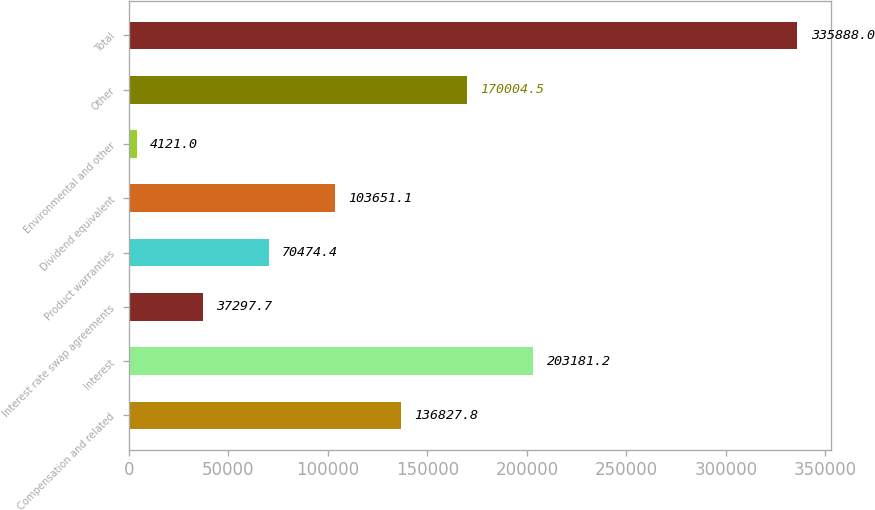Convert chart to OTSL. <chart><loc_0><loc_0><loc_500><loc_500><bar_chart><fcel>Compensation and related<fcel>Interest<fcel>Interest rate swap agreements<fcel>Product warranties<fcel>Dividend equivalent<fcel>Environmental and other<fcel>Other<fcel>Total<nl><fcel>136828<fcel>203181<fcel>37297.7<fcel>70474.4<fcel>103651<fcel>4121<fcel>170004<fcel>335888<nl></chart> 